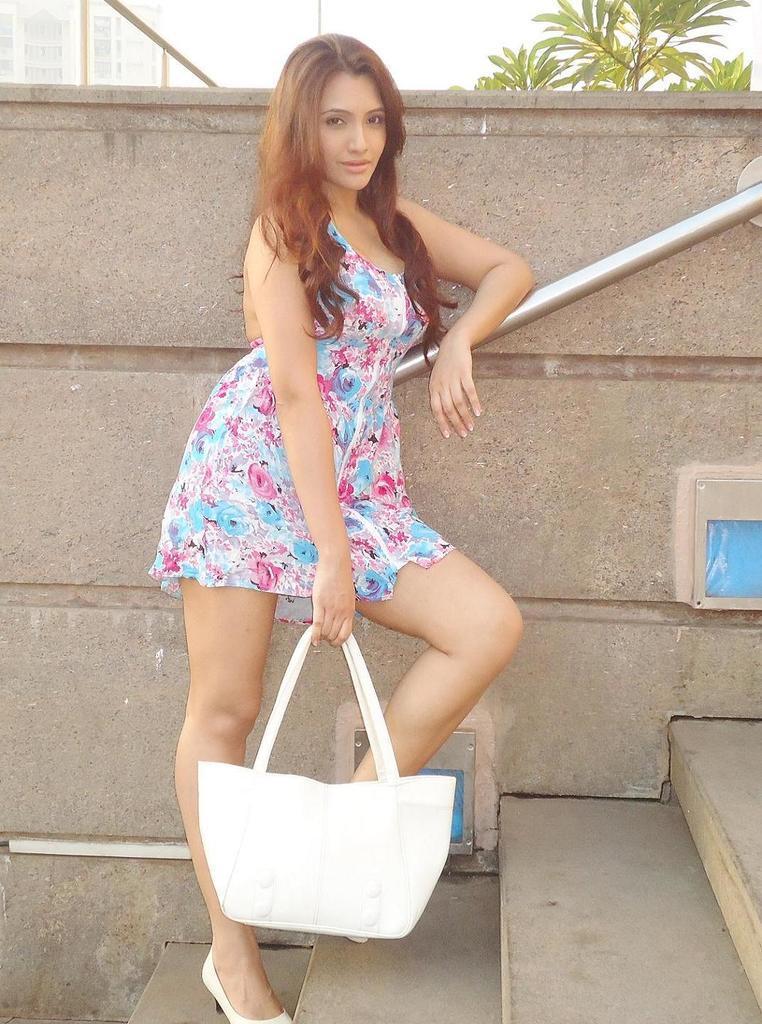Can you describe this image briefly? In this image I can see a person holding the bag. In the background there is a plant. 